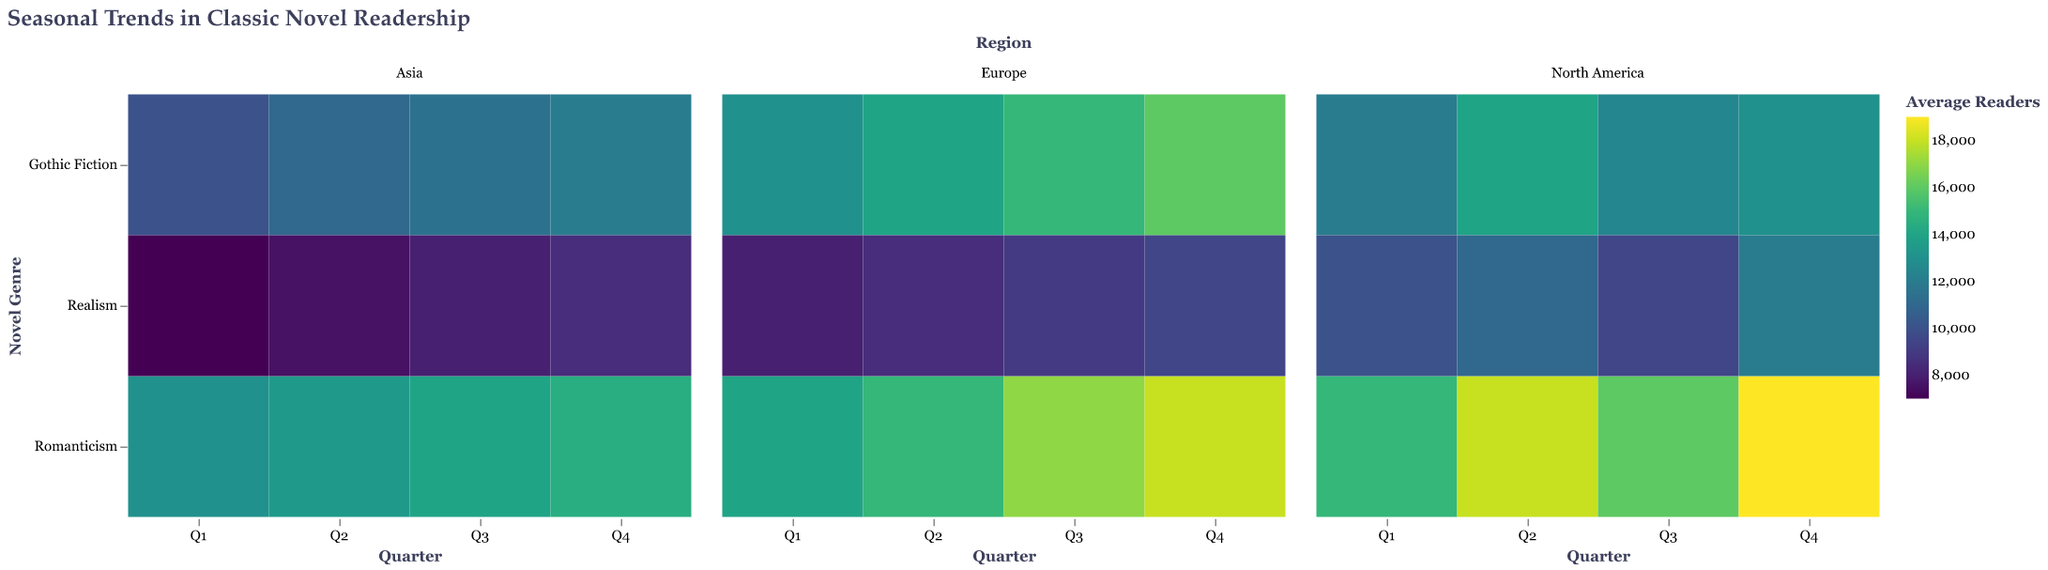What is the title of the figure? The title of the figure is located at the top and provides a brief description of the data represented in the heatmap.
Answer: Seasonal Trends in Classic Novel Readership Which quarter shows the highest average readers for Romanticism in North America? Look at North America's facet, identify the rectangles corresponding to Romanticism, and compare their color intensities. Q4 has the darkest color.
Answer: Q4 Compare the readership of Gothic Fiction in Q1 across regions. Which region has the highest readership? Identify the Gothic Fiction row within Q1 for each region. Compare the color intensities of the rectangles in this row. Europe has the darkest color.
Answer: Europe Is there a notable trend in Realism readership across quarters in Asia? Look at the row for Realism in the Asia facet. Track the color changes from Q1 to Q4. The colors gradually get lighter indicating an increasing trend.
Answer: Yes, it increases gradually Which genre shows the least fluctuation in readership across all quarters in Europe? Look at Europe facet and compare color consistency across quarters for each genre. Romanticism shows the least fluctuation with fairly consistent colors across all quarters.
Answer: Romanticism Which region shows the highest variability in readership for Gothic Fiction across all quarters? Compare the changes in color intensity for Gothic Fiction across quarters in each region. North America displays the greatest variation from Q1 to Q4.
Answer: North America How does the readership of Romanticism in Q3 compare between North America and Asia? Compare the color intensity of Romanticism in Q3 for both North America and Asia. North America's rectangle is darker than Asia's.
Answer: Higher in North America What trend in readership can be observed for Realism from Q3 to Q4 in Europe? Focus on the Realism row in Europe's facet. Observe the color shift from Q3 to Q4. The color gets lighter from Q3 to Q4 indicating a decrease.
Answer: Decreases What can be inferred about the popularity of Gothic Fiction in Q2 across different regions? Look at Gothic Fiction row in Q2 across all regions. Compare the rectangles' color intensities. Europe has the darkest, followed by North America, then Asia.
Answer: Most popular in Europe Which genre in Q1 has the fewest average readers across all regions? Compare the color intensities of all genres in Q1 across all regions. The lightest color indicates the genre with the fewest readers. Realism has the lightest colors.
Answer: Realism 